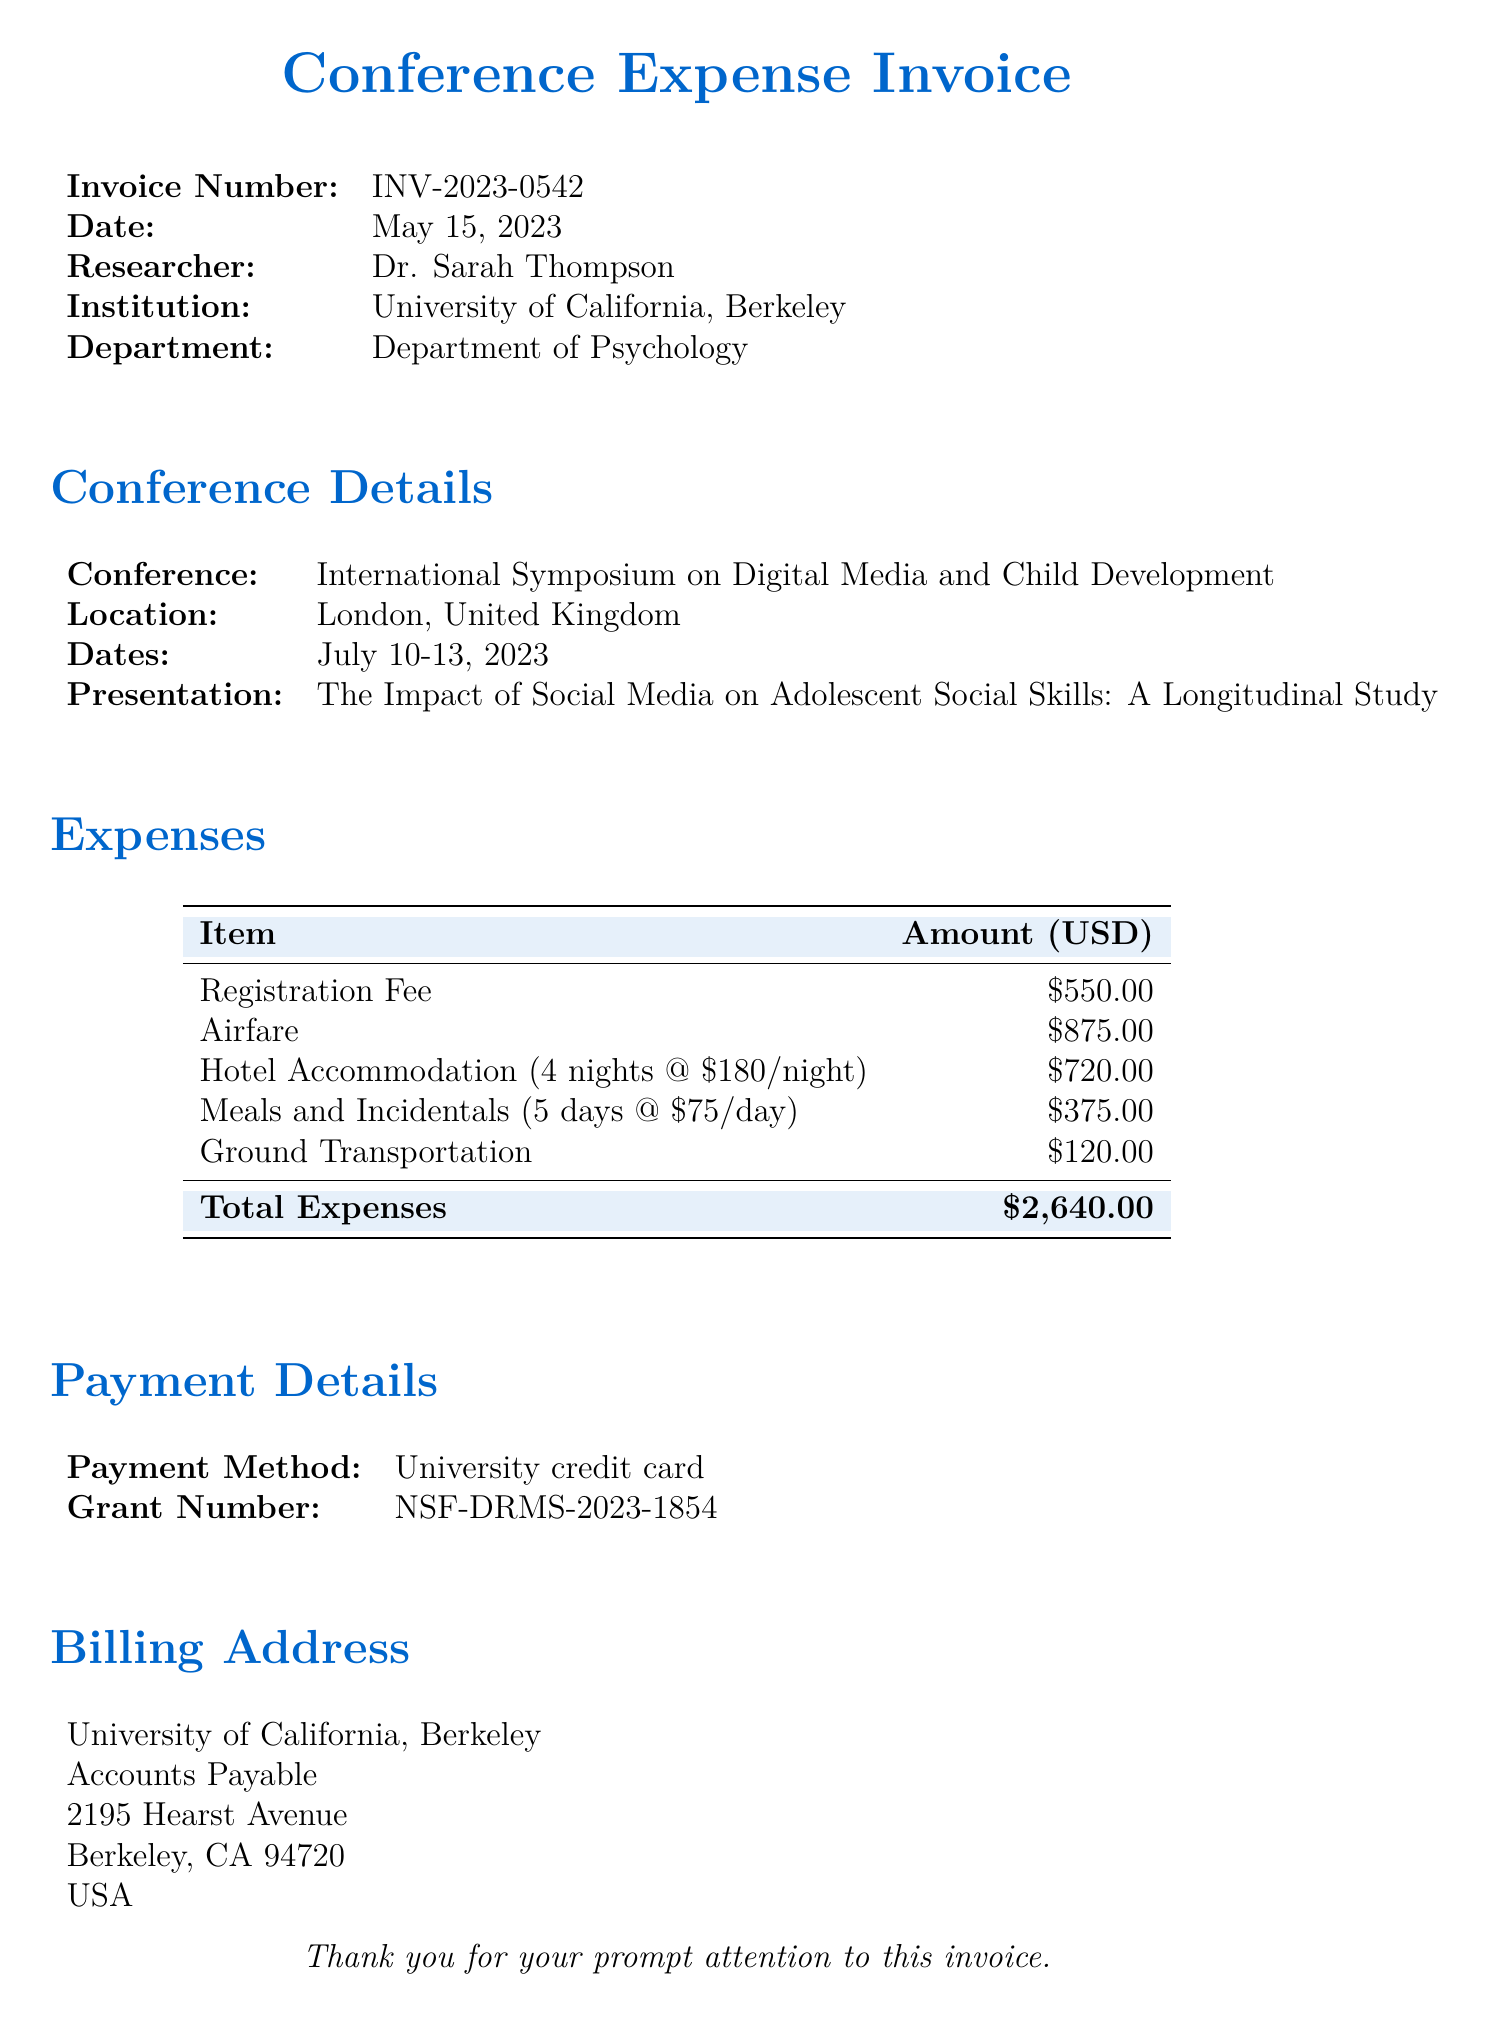What is the invoice number? The invoice number is listed under the Invoice Number section of the document.
Answer: INV-2023-0542 Who is the researcher? The researcher’s name is provided in the invoice section of the document.
Answer: Dr. Sarah Thompson What is the total amount of expenses? The total expenses can be found in the Expenses table, summed across all items.
Answer: $2,640.00 What was the location of the conference? The location of the conference is specified in the Conference Details section.
Answer: London, United Kingdom What method of payment was used? The payment method is indicated under the Payment Details section of the document.
Answer: University credit card How many nights was the hotel accommodation? The hotel accommodation details are provided in the Expenses table, including the duration of stay.
Answer: 4 nights What grant number is associated with this invoice? The grant number is provided in the Payment Details section of the document.
Answer: NSF-DRMS-2023-1854 What is the registration fee? The registration fee is listed as one of the expenses in the Expenses table.
Answer: $550.00 What was the duration of the conference? The dates of the conference indicate its duration, which can be calculated from the provided dates.
Answer: 4 days 